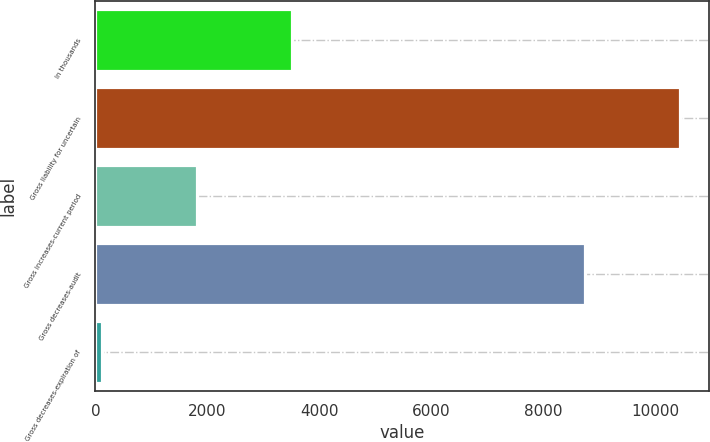Convert chart to OTSL. <chart><loc_0><loc_0><loc_500><loc_500><bar_chart><fcel>In thousands<fcel>Gross liability for uncertain<fcel>Gross increases-current period<fcel>Gross decreases-audit<fcel>Gross decreases-expiration of<nl><fcel>3518<fcel>10451<fcel>1820<fcel>8753<fcel>122<nl></chart> 